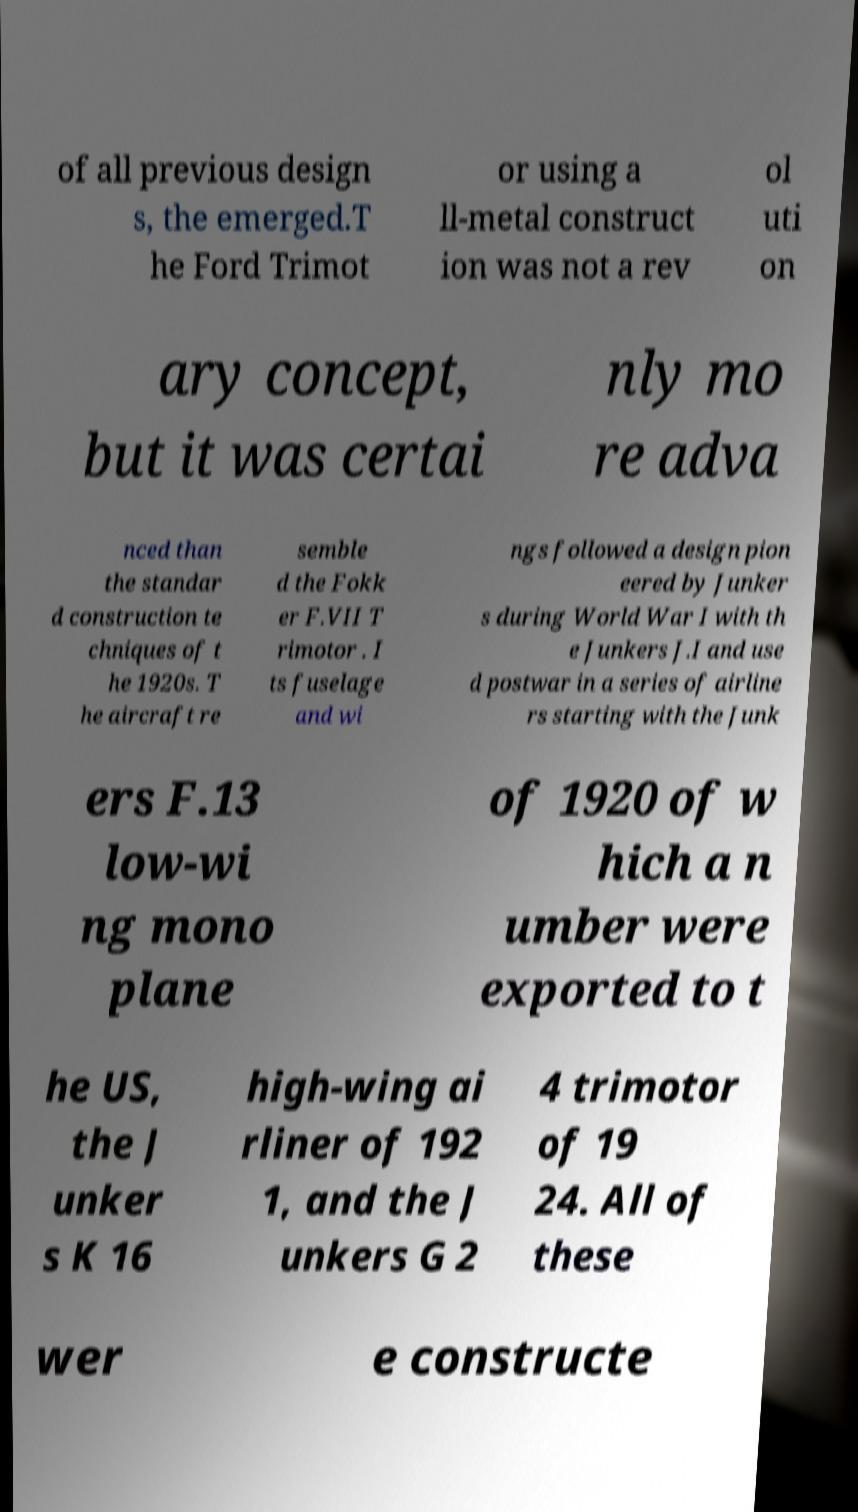Could you assist in decoding the text presented in this image and type it out clearly? of all previous design s, the emerged.T he Ford Trimot or using a ll-metal construct ion was not a rev ol uti on ary concept, but it was certai nly mo re adva nced than the standar d construction te chniques of t he 1920s. T he aircraft re semble d the Fokk er F.VII T rimotor . I ts fuselage and wi ngs followed a design pion eered by Junker s during World War I with th e Junkers J.I and use d postwar in a series of airline rs starting with the Junk ers F.13 low-wi ng mono plane of 1920 of w hich a n umber were exported to t he US, the J unker s K 16 high-wing ai rliner of 192 1, and the J unkers G 2 4 trimotor of 19 24. All of these wer e constructe 